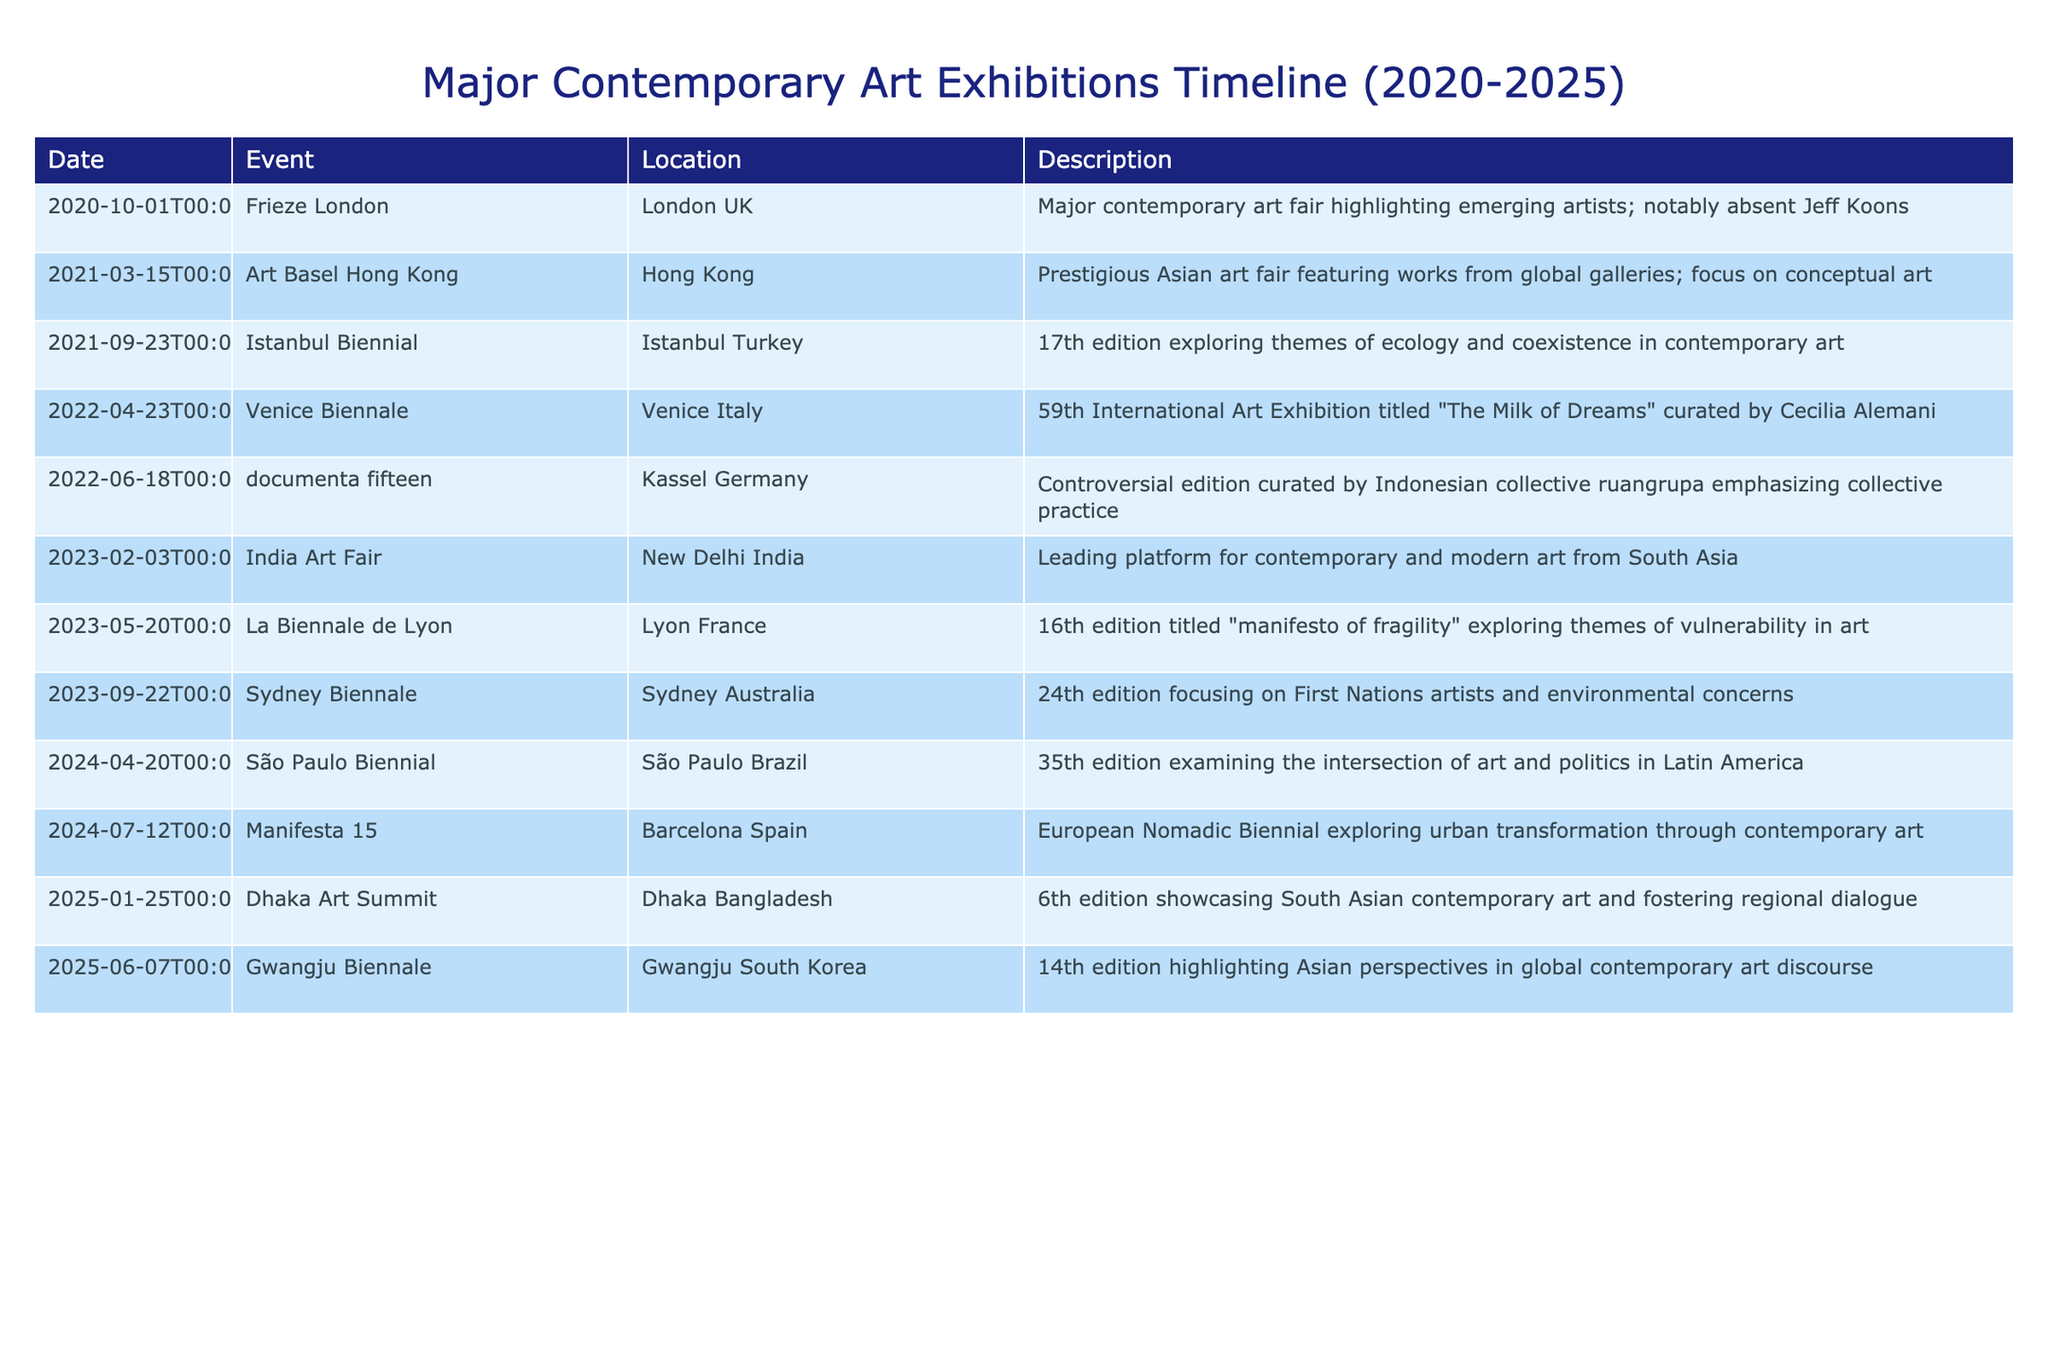What is the date of the Venice Biennale? The table shows that the Venice Biennale took place on April 23, 2022.
Answer: April 23, 2022 Which event occurred last in 2023? According to the table, the last event listed for 2023 is the Sydney Biennale on September 22, 2023.
Answer: Sydney Biennale How many exhibitions took place in 2024? The table indicates two events: the São Paulo Biennial on April 20, 2024, and Manifesta 15 on July 12, 2024. Therefore, there were 2 exhibitions in 2024.
Answer: 2 Was Jeff Koons absent from the Frieze London? The table notes that Jeff Koons was notably absent from the Frieze London event on October 1, 2020.
Answer: Yes Which event in 2025 takes place in South Asia? From the table, the Dhaka Art Summit is the event scheduled for January 25, 2025, which is happening in South Asia.
Answer: Dhaka Art Summit What is the earliest event listed in the table? Looking through the dates, the Frieze London on October 1, 2020, is the earliest event included in the timeline.
Answer: Frieze London How many events are focused on Asian perspectives in the timeline? There are two events highlighted in the table that are focused on Asian perspectives: Art Basel Hong Kong in 2021 and Gwangju Biennale in 2025, totaling 2.
Answer: 2 What are the themes explored by the Sydney Biennale in 2023? The Sydney Biennale focuses on First Nations artists and environmental concerns as mentioned in the table.
Answer: First Nations artists and environmental concerns Which exhibition explores themes of ecology and coexistence? The Istanbul Biennial in 2021 explores these themes, as stated in the description within the table.
Answer: Istanbul Biennial 